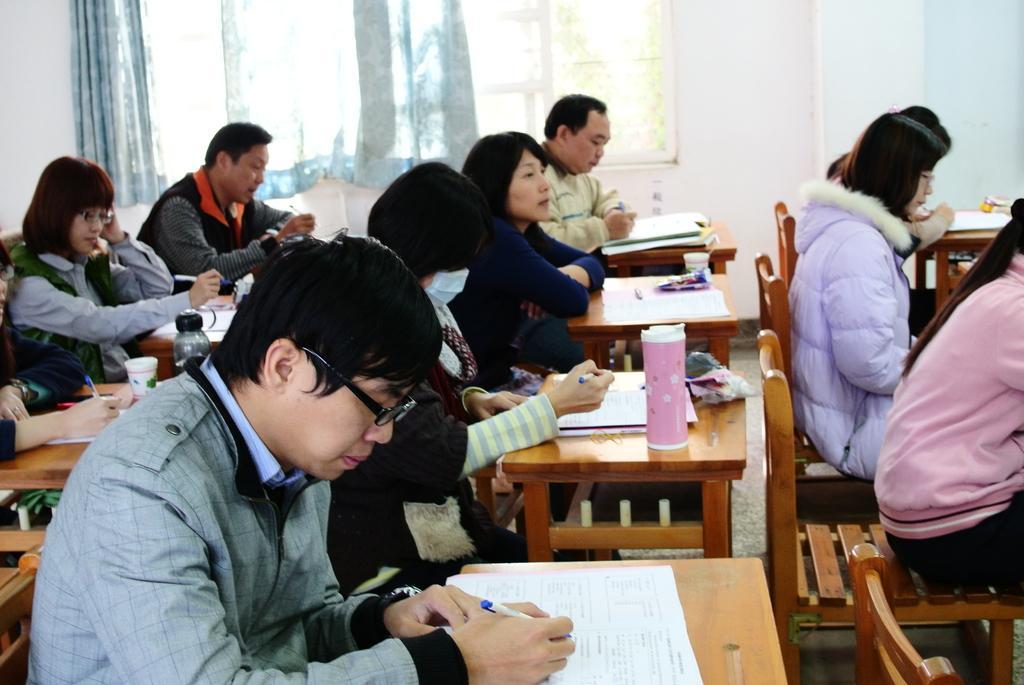Please provide a concise description of this image. In this image there are group of persons who are sitting on the benches and writing something. 